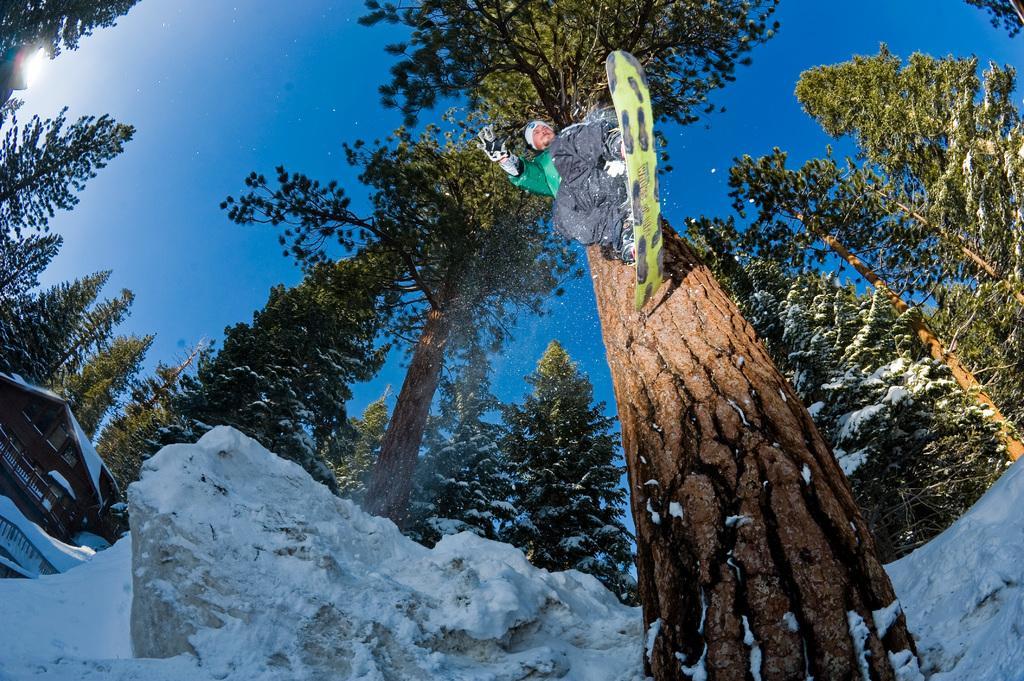Please provide a concise description of this image. This picture shows a building and we see a man standing on the snow board and he wore a cap on his head and gloves to his hands and he is jumping and we see snow and a blue sky. 